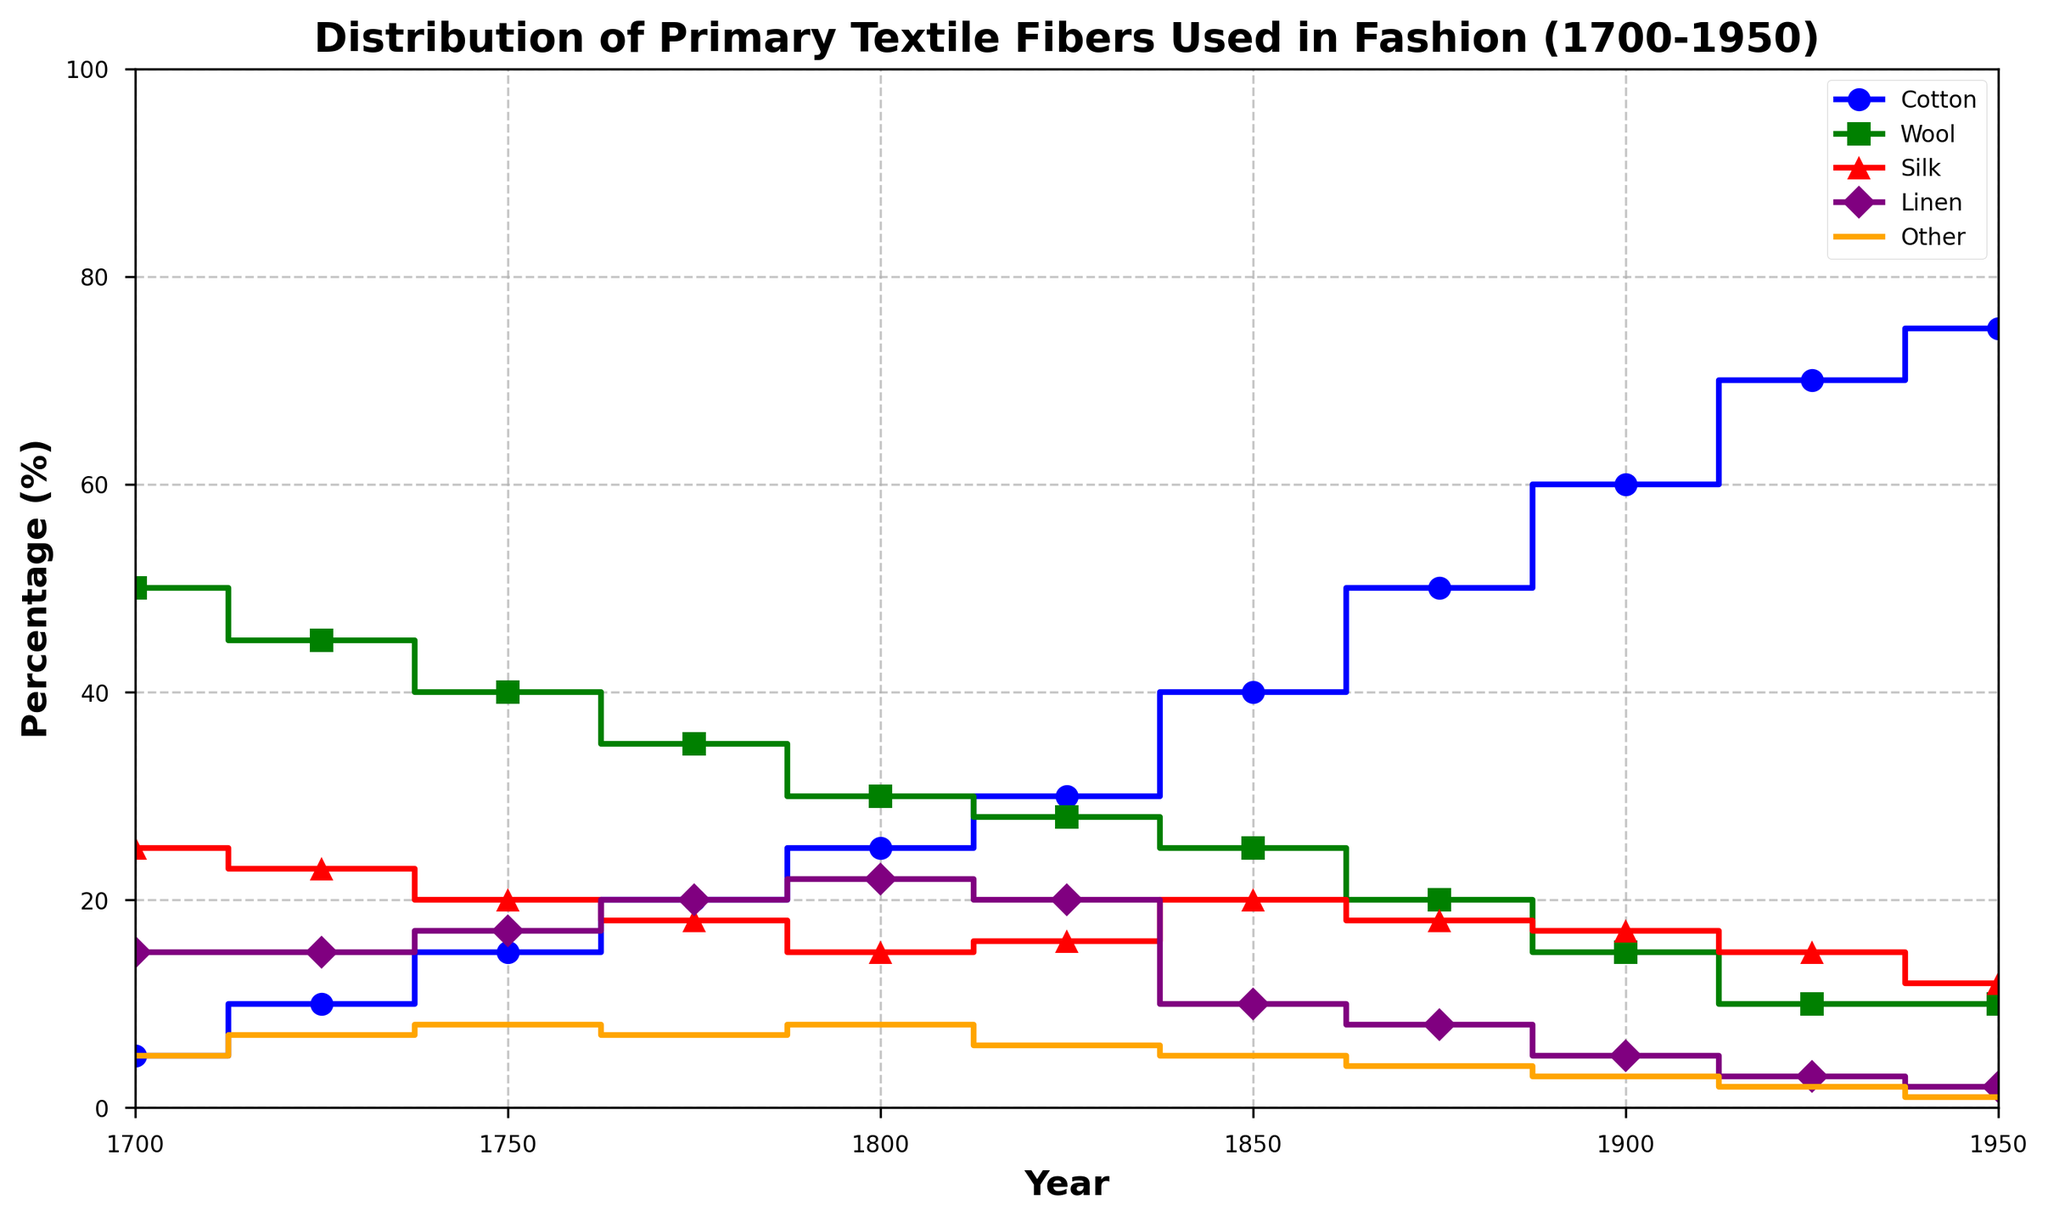What primary textile fiber experienced the highest growth in usage from 1700 to 1950? To answer the question, examine the lines representing each fiber and calculate the difference in their percentages from 1700 to 1950. Cotton increases from 5% to 75%, a growth of 70%, which is the highest relative growth among all materials.
Answer: Cotton Between 1800 and 1850, which textile fiber's percentage of usage remained approximately the same? Measure the change in percentage for each fiber between 1800 and 1850. Cotton increases by 15%, wool decreases by 5%, silk increases by 5%, linen decreases by 12%, and other decreases by 3%. Wool's percentage (30% to 25%) had the smallest change relative to others.
Answer: Wool How did the usage of silk change from 1700 to 1950? Look at the percentage of silk at both endpoints: in 1700, it was 25%, and in 1950, it was 12%. The difference is 25% - 12% = 13%, showing a decrease.
Answer: Decreased by 13% In which year did linen usage reach its peak, according to the plot? Identify the peak point by examining the linen line. The highest percentage for linen is 22%, which occurs around 1800.
Answer: 1800 What's the sum of the percentages for "Other" textiles across all measured years? Add the percentages of "Other" from all years listed: 5 + 7 + 8 + 7 + 8 + 6 + 5 + 4 + 3 + 2 + 1 = 56.
Answer: 56% Which textile fiber had the highest percentage of usage in 1850? Look at the bolded year "1850" on the x-axis and check the highest line value. Cotton is at 40%, which is the highest among all fibers in 1850.
Answer: Cotton How many textile fibers had a decreasing trend in percentage usage from 1700 to 1950? Determine the trend for each fiber by comparing their initial (1700) and final (1950) values. Wool (50% to 10%), silk (25% to 12%), linen (15% to 2%), and the "Other" category (5% to 1%) all show a decrease.
Answer: Four Between 1700 and 1750, which fiber showed the greatest rate of increase? Calculate the rate of increase by subtracting the initial percentage from the final percentage for each fiber between these years. Cotton increased from 5% to 15% (10% increase), wool decreased by 10%, silk decreased by 5%, linen increased by 2%, and other increased by 3%. Cotton's increase was the greatest.
Answer: Cotton In what year did the wool usage drop below 20% for the first time? Trace the wool line and observe the point at which it first falls below 20%. That's between 1850 and 1875, and in 1875 it reaches 20%, then falls further. So, around 1875 is correct.
Answer: 1875 What's the average percentage increase in cotton usage per year from 1700 to 1950? Calculate the total percentage increase (75% - 5% = 70%) and then divide by the number of years (1950 - 1700 = 250): 70/250 = 0.28% per year.
Answer: 0.28% per year 